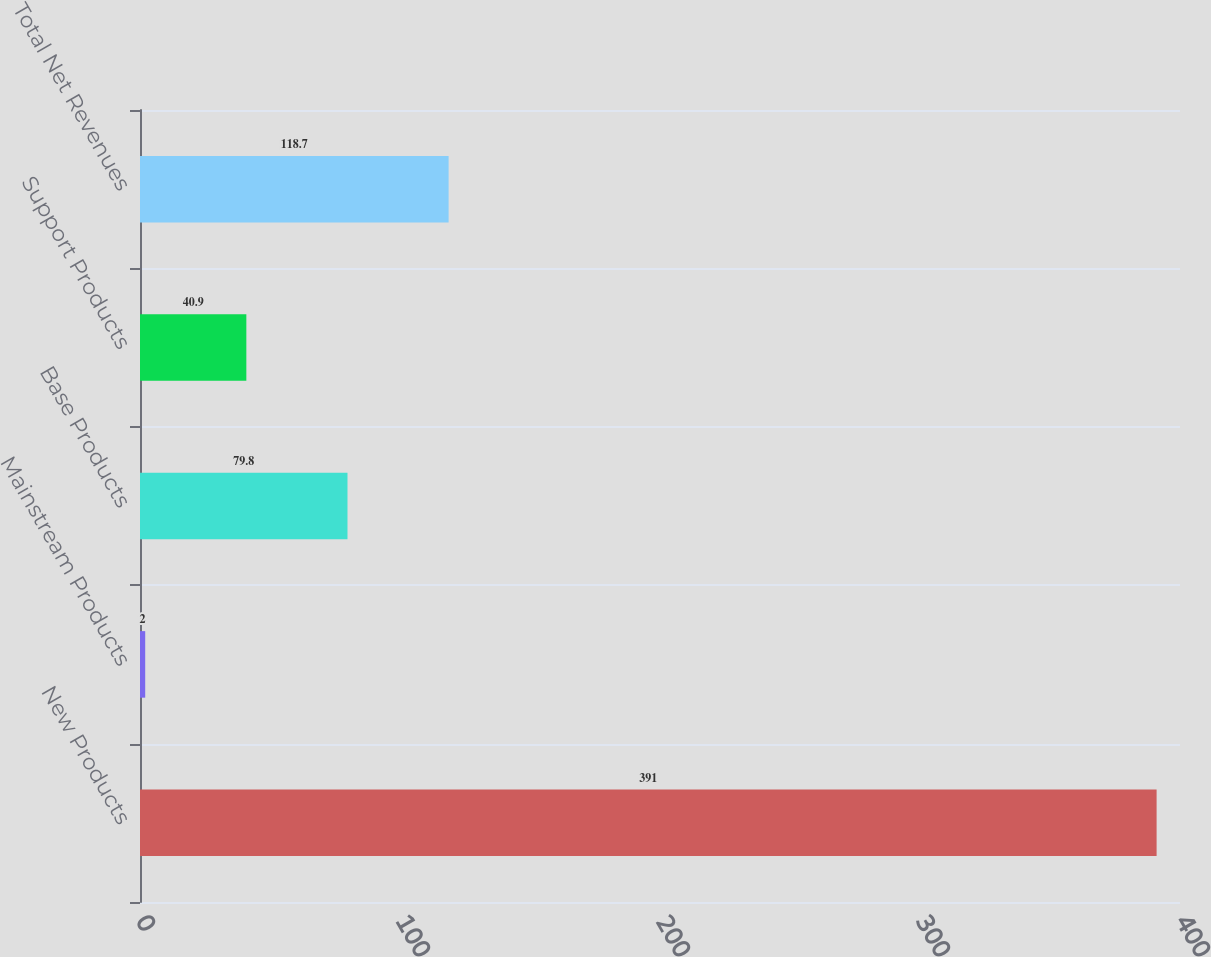Convert chart to OTSL. <chart><loc_0><loc_0><loc_500><loc_500><bar_chart><fcel>New Products<fcel>Mainstream Products<fcel>Base Products<fcel>Support Products<fcel>Total Net Revenues<nl><fcel>391<fcel>2<fcel>79.8<fcel>40.9<fcel>118.7<nl></chart> 